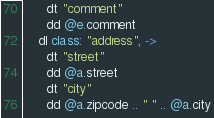<code> <loc_0><loc_0><loc_500><loc_500><_MoonScript_>      dt "comment"
      dd @e.comment
    dl class: "address", ->
      dt "street"
      dd @a.street
      dt "city"
      dd @a.zipcode .. " " .. @a.city

</code> 